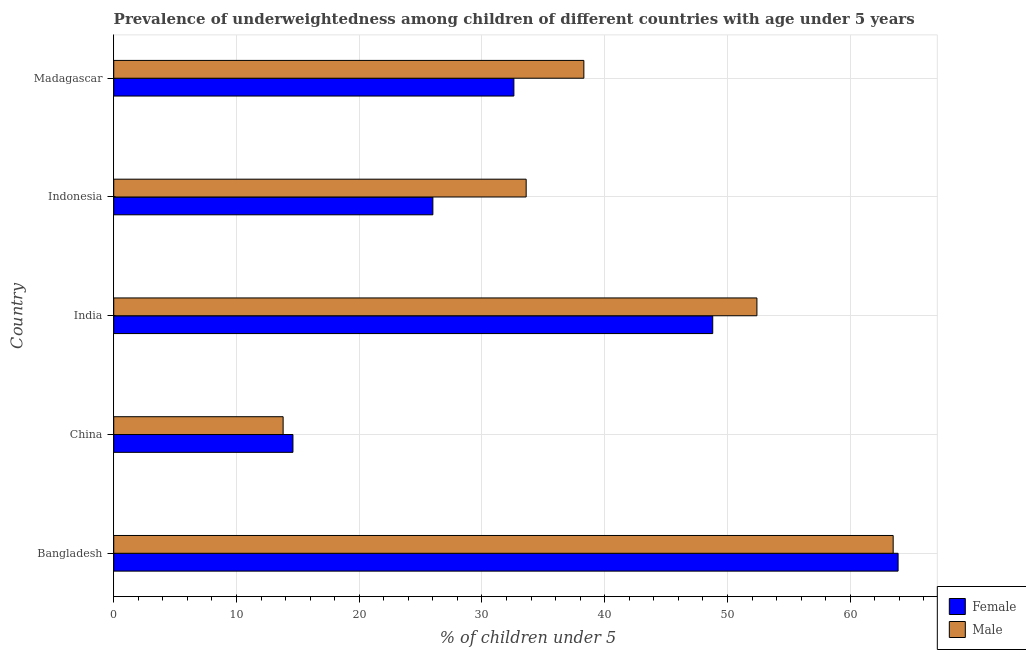How many bars are there on the 2nd tick from the bottom?
Offer a terse response. 2. What is the label of the 5th group of bars from the top?
Your answer should be very brief. Bangladesh. What is the percentage of underweighted female children in Madagascar?
Keep it short and to the point. 32.6. Across all countries, what is the maximum percentage of underweighted female children?
Make the answer very short. 63.9. Across all countries, what is the minimum percentage of underweighted male children?
Provide a short and direct response. 13.8. In which country was the percentage of underweighted female children maximum?
Give a very brief answer. Bangladesh. What is the total percentage of underweighted female children in the graph?
Make the answer very short. 185.9. What is the difference between the percentage of underweighted male children in Bangladesh and that in Madagascar?
Keep it short and to the point. 25.2. What is the difference between the percentage of underweighted male children in Bangladesh and the percentage of underweighted female children in China?
Keep it short and to the point. 48.9. What is the average percentage of underweighted male children per country?
Your response must be concise. 40.32. What is the difference between the percentage of underweighted female children and percentage of underweighted male children in Madagascar?
Offer a very short reply. -5.7. In how many countries, is the percentage of underweighted female children greater than 24 %?
Ensure brevity in your answer.  4. What is the ratio of the percentage of underweighted female children in Bangladesh to that in Indonesia?
Provide a succinct answer. 2.46. Is the difference between the percentage of underweighted male children in Bangladesh and Indonesia greater than the difference between the percentage of underweighted female children in Bangladesh and Indonesia?
Offer a very short reply. No. What is the difference between the highest and the lowest percentage of underweighted female children?
Ensure brevity in your answer.  49.3. In how many countries, is the percentage of underweighted male children greater than the average percentage of underweighted male children taken over all countries?
Give a very brief answer. 2. Is the sum of the percentage of underweighted female children in China and India greater than the maximum percentage of underweighted male children across all countries?
Your answer should be very brief. No. What does the 2nd bar from the bottom in India represents?
Ensure brevity in your answer.  Male. How many bars are there?
Keep it short and to the point. 10. What is the difference between two consecutive major ticks on the X-axis?
Your response must be concise. 10. Does the graph contain any zero values?
Keep it short and to the point. No. Where does the legend appear in the graph?
Offer a terse response. Bottom right. How are the legend labels stacked?
Ensure brevity in your answer.  Vertical. What is the title of the graph?
Ensure brevity in your answer.  Prevalence of underweightedness among children of different countries with age under 5 years. What is the label or title of the X-axis?
Your response must be concise.  % of children under 5. What is the  % of children under 5 of Female in Bangladesh?
Provide a succinct answer. 63.9. What is the  % of children under 5 in Male in Bangladesh?
Keep it short and to the point. 63.5. What is the  % of children under 5 in Female in China?
Ensure brevity in your answer.  14.6. What is the  % of children under 5 of Male in China?
Give a very brief answer. 13.8. What is the  % of children under 5 in Female in India?
Your answer should be very brief. 48.8. What is the  % of children under 5 in Male in India?
Make the answer very short. 52.4. What is the  % of children under 5 in Female in Indonesia?
Offer a terse response. 26. What is the  % of children under 5 of Male in Indonesia?
Your answer should be compact. 33.6. What is the  % of children under 5 of Female in Madagascar?
Make the answer very short. 32.6. What is the  % of children under 5 in Male in Madagascar?
Provide a short and direct response. 38.3. Across all countries, what is the maximum  % of children under 5 in Female?
Provide a succinct answer. 63.9. Across all countries, what is the maximum  % of children under 5 of Male?
Give a very brief answer. 63.5. Across all countries, what is the minimum  % of children under 5 in Female?
Give a very brief answer. 14.6. Across all countries, what is the minimum  % of children under 5 of Male?
Provide a short and direct response. 13.8. What is the total  % of children under 5 in Female in the graph?
Keep it short and to the point. 185.9. What is the total  % of children under 5 in Male in the graph?
Your response must be concise. 201.6. What is the difference between the  % of children under 5 of Female in Bangladesh and that in China?
Ensure brevity in your answer.  49.3. What is the difference between the  % of children under 5 in Male in Bangladesh and that in China?
Your answer should be very brief. 49.7. What is the difference between the  % of children under 5 of Female in Bangladesh and that in India?
Offer a very short reply. 15.1. What is the difference between the  % of children under 5 of Female in Bangladesh and that in Indonesia?
Provide a succinct answer. 37.9. What is the difference between the  % of children under 5 of Male in Bangladesh and that in Indonesia?
Provide a short and direct response. 29.9. What is the difference between the  % of children under 5 in Female in Bangladesh and that in Madagascar?
Your response must be concise. 31.3. What is the difference between the  % of children under 5 of Male in Bangladesh and that in Madagascar?
Make the answer very short. 25.2. What is the difference between the  % of children under 5 of Female in China and that in India?
Give a very brief answer. -34.2. What is the difference between the  % of children under 5 in Male in China and that in India?
Your response must be concise. -38.6. What is the difference between the  % of children under 5 in Male in China and that in Indonesia?
Provide a succinct answer. -19.8. What is the difference between the  % of children under 5 of Male in China and that in Madagascar?
Provide a succinct answer. -24.5. What is the difference between the  % of children under 5 of Female in India and that in Indonesia?
Your answer should be very brief. 22.8. What is the difference between the  % of children under 5 in Female in India and that in Madagascar?
Your answer should be compact. 16.2. What is the difference between the  % of children under 5 in Male in India and that in Madagascar?
Provide a short and direct response. 14.1. What is the difference between the  % of children under 5 of Male in Indonesia and that in Madagascar?
Your answer should be very brief. -4.7. What is the difference between the  % of children under 5 in Female in Bangladesh and the  % of children under 5 in Male in China?
Your response must be concise. 50.1. What is the difference between the  % of children under 5 in Female in Bangladesh and the  % of children under 5 in Male in Indonesia?
Give a very brief answer. 30.3. What is the difference between the  % of children under 5 of Female in Bangladesh and the  % of children under 5 of Male in Madagascar?
Provide a succinct answer. 25.6. What is the difference between the  % of children under 5 in Female in China and the  % of children under 5 in Male in India?
Your answer should be very brief. -37.8. What is the difference between the  % of children under 5 in Female in China and the  % of children under 5 in Male in Madagascar?
Your answer should be very brief. -23.7. What is the difference between the  % of children under 5 of Female in India and the  % of children under 5 of Male in Madagascar?
Provide a short and direct response. 10.5. What is the average  % of children under 5 in Female per country?
Your answer should be compact. 37.18. What is the average  % of children under 5 of Male per country?
Provide a succinct answer. 40.32. What is the difference between the  % of children under 5 in Female and  % of children under 5 in Male in Bangladesh?
Your answer should be very brief. 0.4. What is the difference between the  % of children under 5 of Female and  % of children under 5 of Male in India?
Provide a succinct answer. -3.6. What is the difference between the  % of children under 5 of Female and  % of children under 5 of Male in Indonesia?
Give a very brief answer. -7.6. What is the ratio of the  % of children under 5 in Female in Bangladesh to that in China?
Provide a short and direct response. 4.38. What is the ratio of the  % of children under 5 of Male in Bangladesh to that in China?
Ensure brevity in your answer.  4.6. What is the ratio of the  % of children under 5 in Female in Bangladesh to that in India?
Ensure brevity in your answer.  1.31. What is the ratio of the  % of children under 5 of Male in Bangladesh to that in India?
Your answer should be compact. 1.21. What is the ratio of the  % of children under 5 in Female in Bangladesh to that in Indonesia?
Your response must be concise. 2.46. What is the ratio of the  % of children under 5 in Male in Bangladesh to that in Indonesia?
Ensure brevity in your answer.  1.89. What is the ratio of the  % of children under 5 of Female in Bangladesh to that in Madagascar?
Your response must be concise. 1.96. What is the ratio of the  % of children under 5 of Male in Bangladesh to that in Madagascar?
Make the answer very short. 1.66. What is the ratio of the  % of children under 5 of Female in China to that in India?
Offer a very short reply. 0.3. What is the ratio of the  % of children under 5 in Male in China to that in India?
Give a very brief answer. 0.26. What is the ratio of the  % of children under 5 of Female in China to that in Indonesia?
Keep it short and to the point. 0.56. What is the ratio of the  % of children under 5 of Male in China to that in Indonesia?
Make the answer very short. 0.41. What is the ratio of the  % of children under 5 in Female in China to that in Madagascar?
Provide a succinct answer. 0.45. What is the ratio of the  % of children under 5 in Male in China to that in Madagascar?
Keep it short and to the point. 0.36. What is the ratio of the  % of children under 5 of Female in India to that in Indonesia?
Offer a terse response. 1.88. What is the ratio of the  % of children under 5 of Male in India to that in Indonesia?
Your response must be concise. 1.56. What is the ratio of the  % of children under 5 in Female in India to that in Madagascar?
Your response must be concise. 1.5. What is the ratio of the  % of children under 5 of Male in India to that in Madagascar?
Your answer should be compact. 1.37. What is the ratio of the  % of children under 5 of Female in Indonesia to that in Madagascar?
Offer a very short reply. 0.8. What is the ratio of the  % of children under 5 of Male in Indonesia to that in Madagascar?
Make the answer very short. 0.88. What is the difference between the highest and the second highest  % of children under 5 of Male?
Keep it short and to the point. 11.1. What is the difference between the highest and the lowest  % of children under 5 in Female?
Offer a terse response. 49.3. What is the difference between the highest and the lowest  % of children under 5 of Male?
Give a very brief answer. 49.7. 